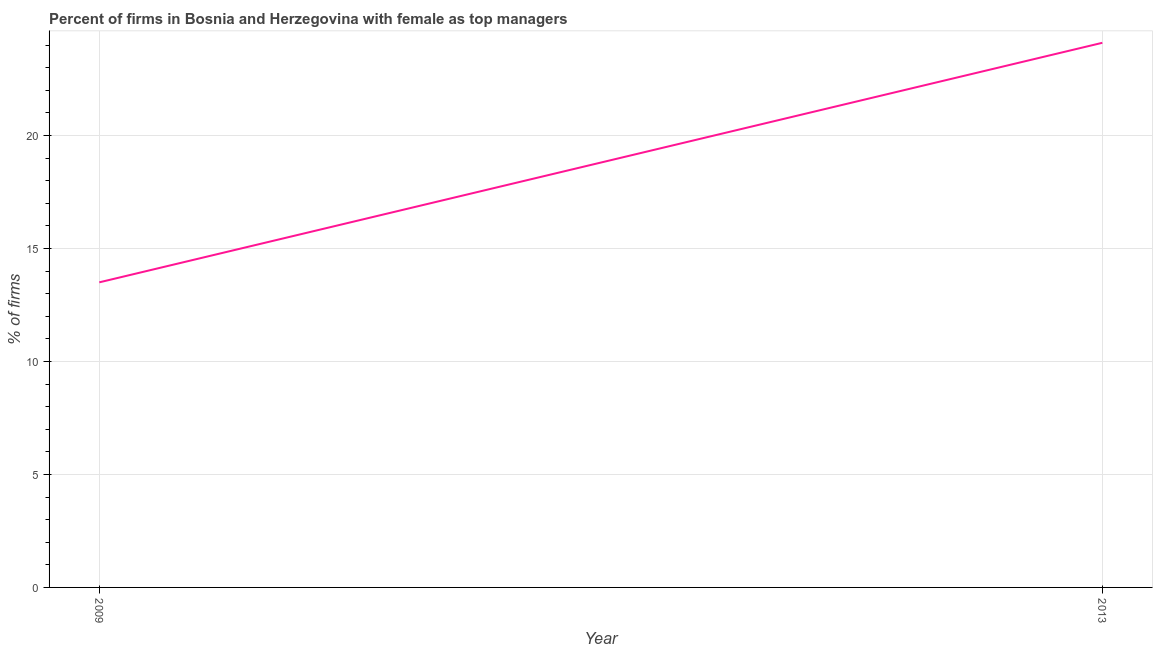What is the percentage of firms with female as top manager in 2009?
Give a very brief answer. 13.5. Across all years, what is the maximum percentage of firms with female as top manager?
Your answer should be very brief. 24.1. In which year was the percentage of firms with female as top manager maximum?
Make the answer very short. 2013. In which year was the percentage of firms with female as top manager minimum?
Your response must be concise. 2009. What is the sum of the percentage of firms with female as top manager?
Ensure brevity in your answer.  37.6. What is the difference between the percentage of firms with female as top manager in 2009 and 2013?
Provide a succinct answer. -10.6. What is the average percentage of firms with female as top manager per year?
Provide a succinct answer. 18.8. In how many years, is the percentage of firms with female as top manager greater than 16 %?
Your answer should be very brief. 1. Do a majority of the years between 2013 and 2009 (inclusive) have percentage of firms with female as top manager greater than 20 %?
Your response must be concise. No. What is the ratio of the percentage of firms with female as top manager in 2009 to that in 2013?
Ensure brevity in your answer.  0.56. In how many years, is the percentage of firms with female as top manager greater than the average percentage of firms with female as top manager taken over all years?
Give a very brief answer. 1. Does the percentage of firms with female as top manager monotonically increase over the years?
Your answer should be very brief. Yes. How many years are there in the graph?
Provide a short and direct response. 2. What is the difference between two consecutive major ticks on the Y-axis?
Your answer should be compact. 5. Does the graph contain any zero values?
Provide a short and direct response. No. Does the graph contain grids?
Your response must be concise. Yes. What is the title of the graph?
Provide a succinct answer. Percent of firms in Bosnia and Herzegovina with female as top managers. What is the label or title of the Y-axis?
Ensure brevity in your answer.  % of firms. What is the % of firms of 2013?
Offer a terse response. 24.1. What is the difference between the % of firms in 2009 and 2013?
Offer a terse response. -10.6. What is the ratio of the % of firms in 2009 to that in 2013?
Provide a short and direct response. 0.56. 